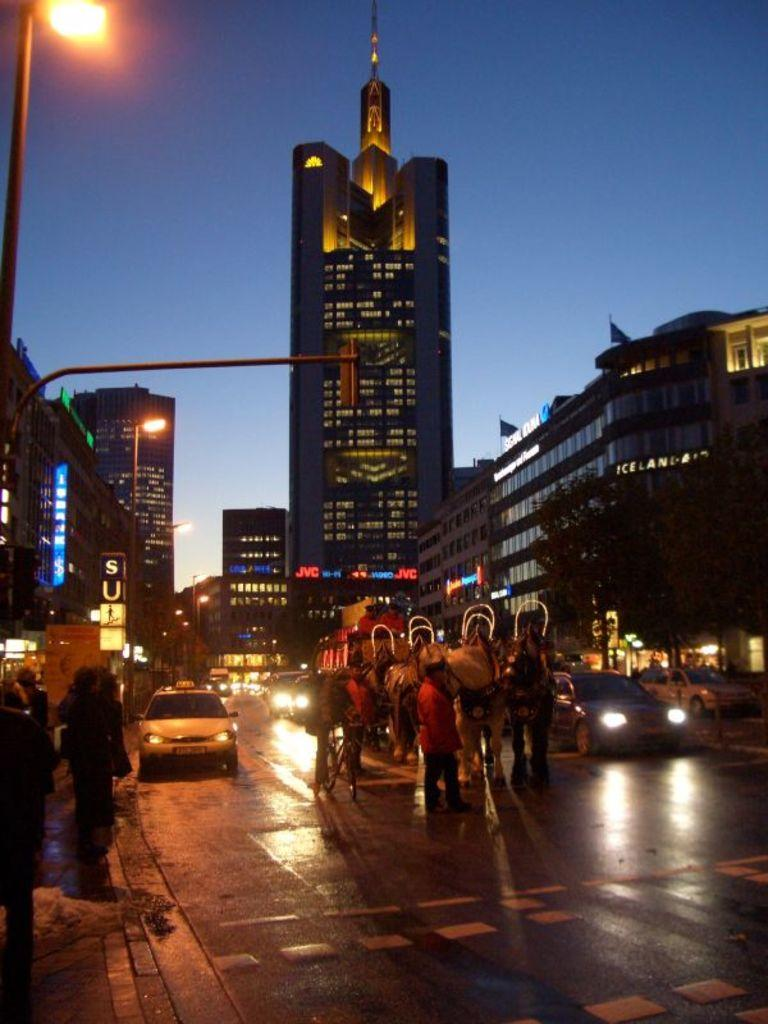What can be seen on the road in the image? There are vehicles and persons on the road in the image. What structures are visible on either side of the road? There are buildings on either side of the road. What type of vegetation is present in the image? There are trees in the right corner of the image. Can you tell me how many receipts are visible in the image? There are no receipts present in the image. What type of lettuce can be seen growing on the side of the road? There is no lettuce visible in the image; only trees are present in the right corner. 